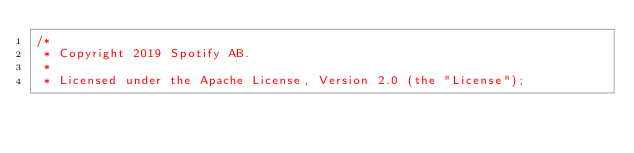Convert code to text. <code><loc_0><loc_0><loc_500><loc_500><_Scala_>/*
 * Copyright 2019 Spotify AB.
 *
 * Licensed under the Apache License, Version 2.0 (the "License");</code> 